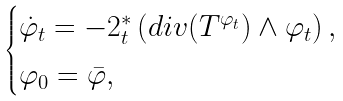<formula> <loc_0><loc_0><loc_500><loc_500>\begin{cases} \dot { \varphi } _ { t } = - 2 ^ { * } _ { t } \left ( d i v ( T ^ { \varphi _ { t } } ) \wedge \varphi _ { t } \right ) , \\ \varphi _ { 0 } = \bar { \varphi } , \end{cases}</formula> 